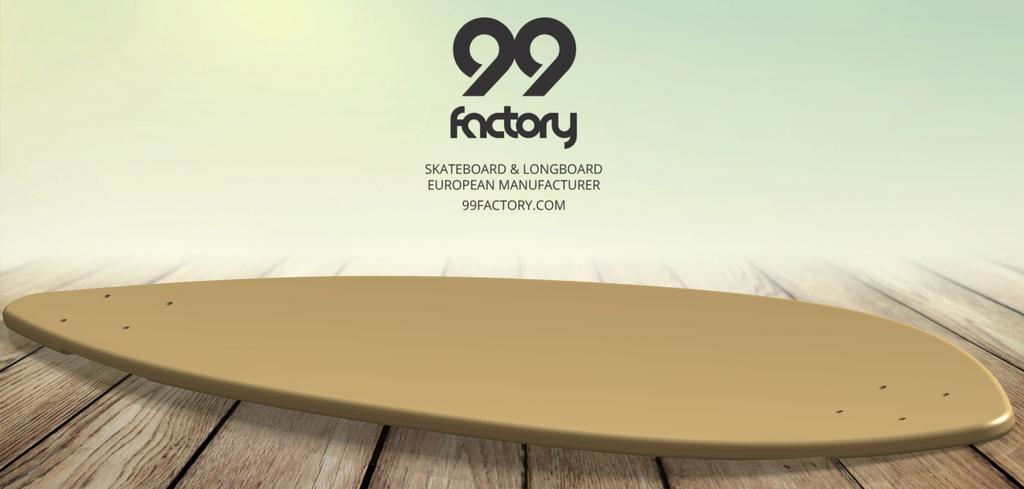What is the main object in the image? There is a skateboard in the image. What is the skateboard resting on? The skateboard is on a wooden surface. What else can be seen in the image besides the skateboard? There is text and a logo in the image. How many clovers are growing around the skateboard in the image? There are no clovers present in the image. Can you describe the woman standing next to the skateboard in the image? There is no woman present in the image. 